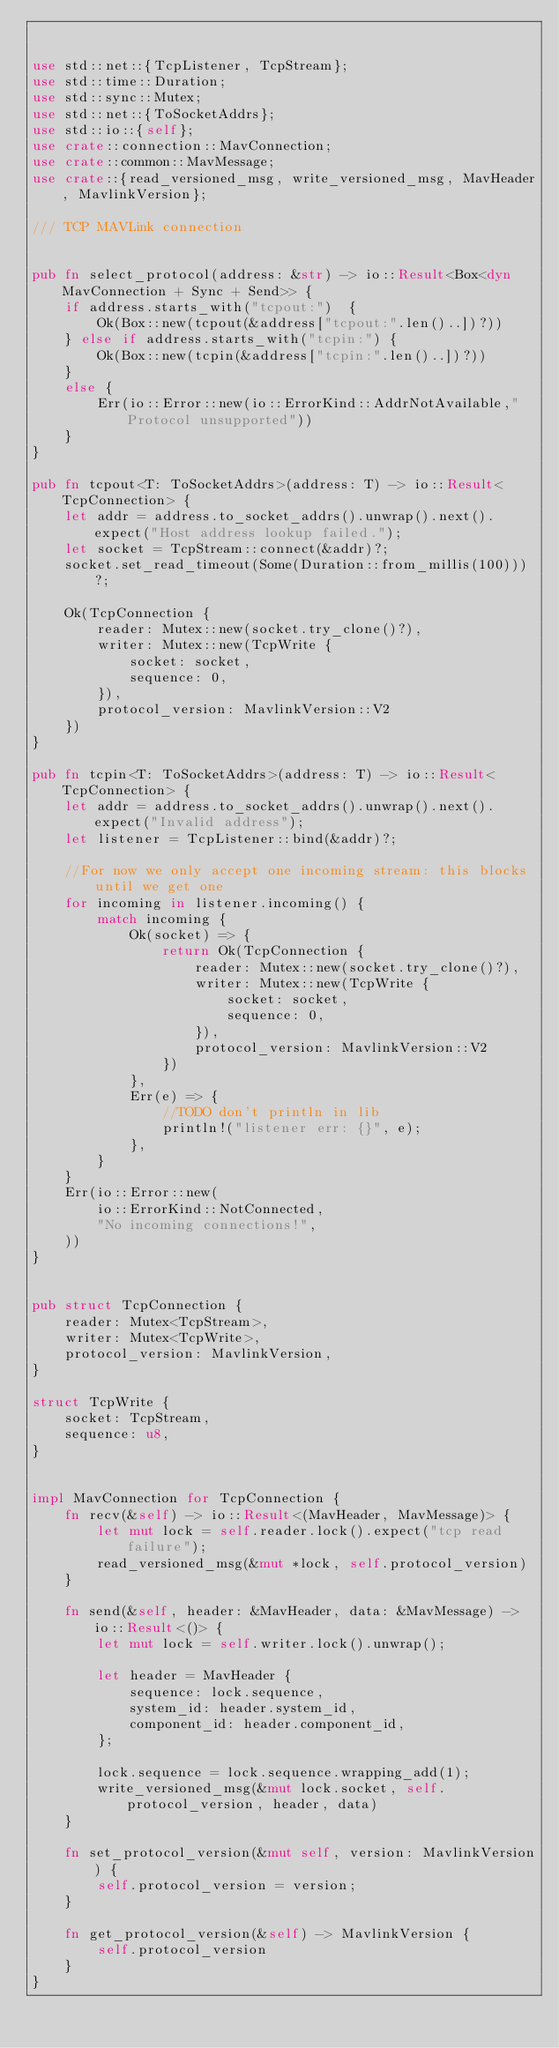<code> <loc_0><loc_0><loc_500><loc_500><_Rust_>

use std::net::{TcpListener, TcpStream};
use std::time::Duration;
use std::sync::Mutex;
use std::net::{ToSocketAddrs};
use std::io::{self};
use crate::connection::MavConnection;
use crate::common::MavMessage;
use crate::{read_versioned_msg, write_versioned_msg, MavHeader, MavlinkVersion};

/// TCP MAVLink connection


pub fn select_protocol(address: &str) -> io::Result<Box<dyn MavConnection + Sync + Send>> {
    if address.starts_with("tcpout:")  {
        Ok(Box::new(tcpout(&address["tcpout:".len()..])?))
    } else if address.starts_with("tcpin:") {
        Ok(Box::new(tcpin(&address["tcpin:".len()..])?))
    }
    else {
        Err(io::Error::new(io::ErrorKind::AddrNotAvailable,"Protocol unsupported"))
    }
}

pub fn tcpout<T: ToSocketAddrs>(address: T) -> io::Result<TcpConnection> {
    let addr = address.to_socket_addrs().unwrap().next().expect("Host address lookup failed.");
    let socket = TcpStream::connect(&addr)?;
    socket.set_read_timeout(Some(Duration::from_millis(100)))?;

    Ok(TcpConnection {
        reader: Mutex::new(socket.try_clone()?),
        writer: Mutex::new(TcpWrite {
            socket: socket,
            sequence: 0,
        }),
        protocol_version: MavlinkVersion::V2
    })
}

pub fn tcpin<T: ToSocketAddrs>(address: T) -> io::Result<TcpConnection> {
    let addr = address.to_socket_addrs().unwrap().next().expect("Invalid address");
    let listener = TcpListener::bind(&addr)?;

    //For now we only accept one incoming stream: this blocks until we get one
    for incoming in listener.incoming() {
        match incoming {
            Ok(socket) => {
                return Ok(TcpConnection {
                    reader: Mutex::new(socket.try_clone()?),
                    writer: Mutex::new(TcpWrite {
                        socket: socket,
                        sequence: 0,
                    }),
                    protocol_version: MavlinkVersion::V2
                })
            },
            Err(e) => {
                //TODO don't println in lib
                println!("listener err: {}", e);
            },
        }
    }
    Err(io::Error::new(
        io::ErrorKind::NotConnected,
        "No incoming connections!",
    ))
}


pub struct TcpConnection {
    reader: Mutex<TcpStream>,
    writer: Mutex<TcpWrite>,
    protocol_version: MavlinkVersion,
}

struct TcpWrite {
    socket: TcpStream,
    sequence: u8,
}


impl MavConnection for TcpConnection {
    fn recv(&self) -> io::Result<(MavHeader, MavMessage)> {
        let mut lock = self.reader.lock().expect("tcp read failure");
        read_versioned_msg(&mut *lock, self.protocol_version)
    }

    fn send(&self, header: &MavHeader, data: &MavMessage) -> io::Result<()> {
        let mut lock = self.writer.lock().unwrap();

        let header = MavHeader {
            sequence: lock.sequence,
            system_id: header.system_id,
            component_id: header.component_id,
        };

        lock.sequence = lock.sequence.wrapping_add(1);
        write_versioned_msg(&mut lock.socket, self.protocol_version, header, data)
    }

    fn set_protocol_version(&mut self, version: MavlinkVersion) {
        self.protocol_version = version;
    }

    fn get_protocol_version(&self) -> MavlinkVersion {
        self.protocol_version
    }
}
</code> 